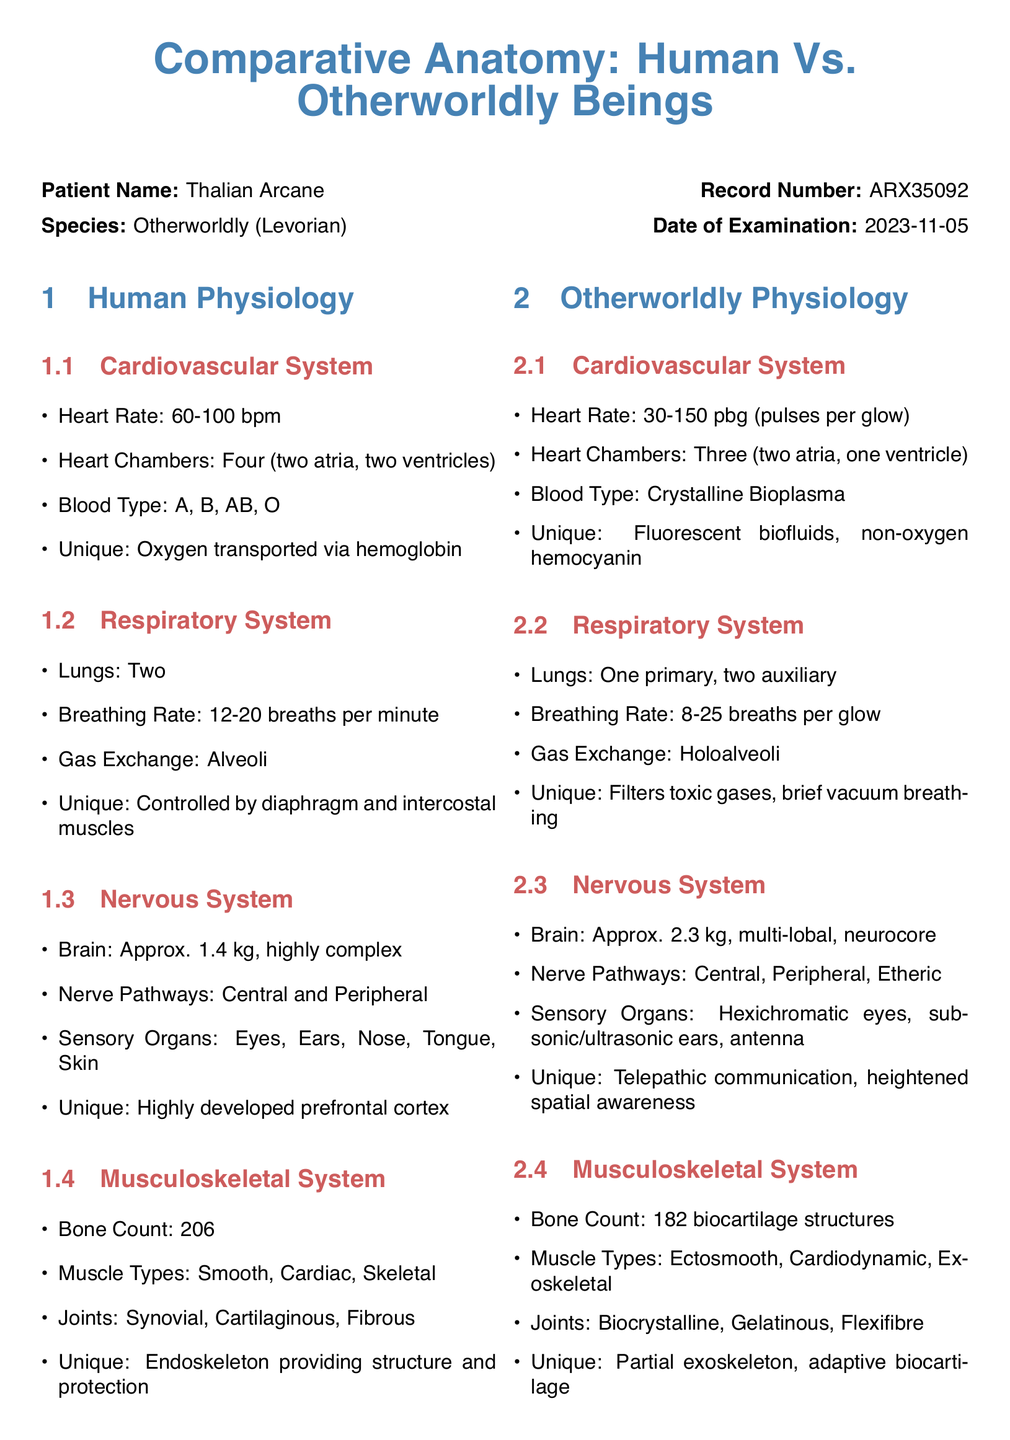What is the heart rate range for humans? The human heart rate is defined as 60-100 bpm in the document.
Answer: 60-100 bpm How many chambers does the Levorian heart have? According to the document, the Levorian heart has three chambers.
Answer: Three What is the unique feature of the human respiratory system? The document states that the unique aspect of the human respiratory system is its control by the diaphragm and intercostal muscles.
Answer: Controlled by diaphragm and intercostal muscles What type of blood do Levorian beings have? The document mentions that Levorian beings have Crystalline Bioplasma as their blood type.
Answer: Crystalline Bioplasma How many bones does a Levorian have? The document states that a Levorian has 182 biocartilage structures.
Answer: 182 What is a unique feature of the nervous system in Levorian beings? The document indicates that Levorian beings have telepathic communication as a unique feature of their nervous system.
Answer: Telepathic communication What is the date of examination for Thalian Arcane? The date of examination mentioned in the document is 2023-11-05.
Answer: 2023-11-05 Who is the examining physician? The document states that the examining physician is Dr. Elara Montrose.
Answer: Dr. Elara Montrose What is the total count of human bones? According to the document, humans have a total of 206 bones.
Answer: 206 